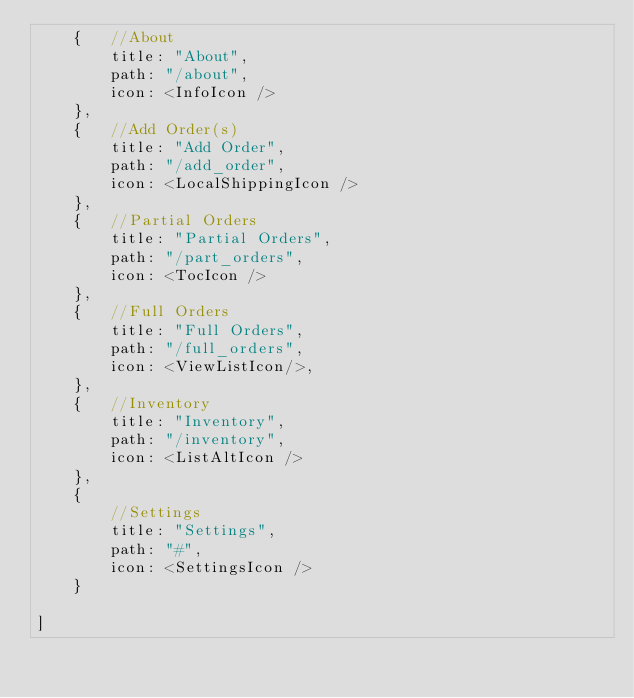Convert code to text. <code><loc_0><loc_0><loc_500><loc_500><_JavaScript_>    {   //About
        title: "About",
        path: "/about",
        icon: <InfoIcon />
    },
    {   //Add Order(s)
        title: "Add Order",
        path: "/add_order",
        icon: <LocalShippingIcon />  
    },
    {   //Partial Orders
        title: "Partial Orders",
        path: "/part_orders",
        icon: <TocIcon />
    },
    {   //Full Orders
        title: "Full Orders",
        path: "/full_orders",
        icon: <ViewListIcon/>,
    },
    {   //Inventory
        title: "Inventory",
        path: "/inventory",
        icon: <ListAltIcon />
    },
    {
        //Settings 
        title: "Settings",
        path: "#",
        icon: <SettingsIcon />
    }
    
]</code> 